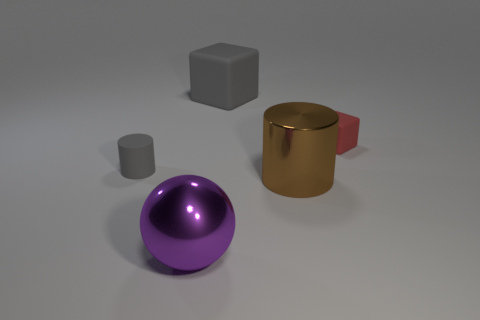Subtract all red cubes. How many cubes are left? 1 Add 3 tiny yellow metallic cylinders. How many objects exist? 8 Subtract all cylinders. How many objects are left? 3 Subtract 1 cubes. How many cubes are left? 1 Add 4 tiny matte cylinders. How many tiny matte cylinders are left? 5 Add 1 large cubes. How many large cubes exist? 2 Subtract 0 green cylinders. How many objects are left? 5 Subtract all green spheres. Subtract all blue blocks. How many spheres are left? 1 Subtract all blue cylinders. How many red cubes are left? 1 Subtract all cyan metal cylinders. Subtract all large matte cubes. How many objects are left? 4 